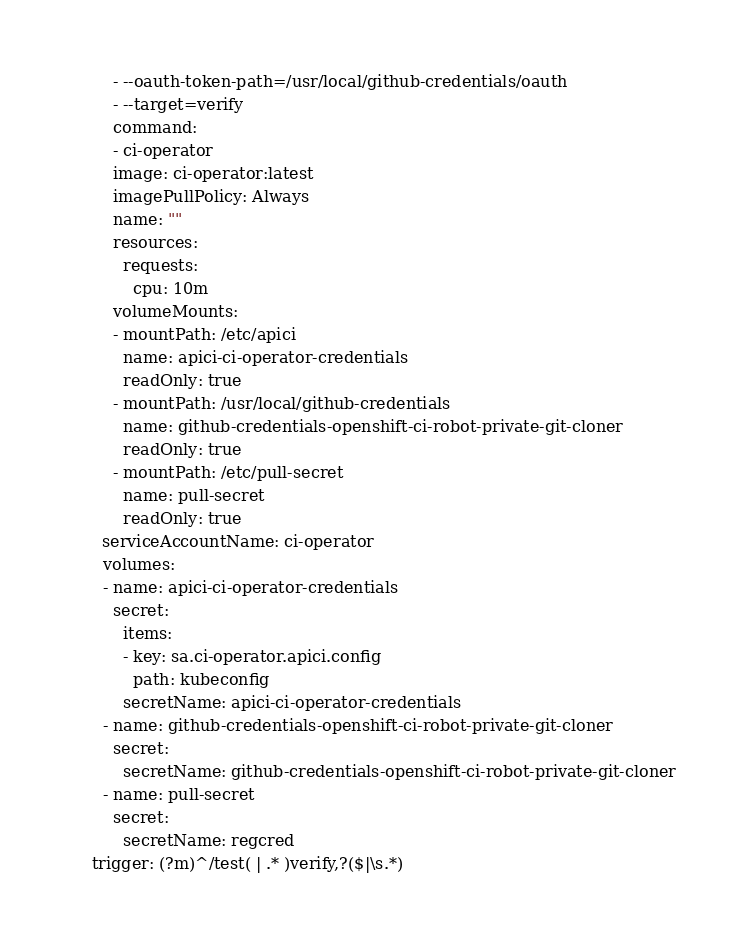<code> <loc_0><loc_0><loc_500><loc_500><_YAML_>        - --oauth-token-path=/usr/local/github-credentials/oauth
        - --target=verify
        command:
        - ci-operator
        image: ci-operator:latest
        imagePullPolicy: Always
        name: ""
        resources:
          requests:
            cpu: 10m
        volumeMounts:
        - mountPath: /etc/apici
          name: apici-ci-operator-credentials
          readOnly: true
        - mountPath: /usr/local/github-credentials
          name: github-credentials-openshift-ci-robot-private-git-cloner
          readOnly: true
        - mountPath: /etc/pull-secret
          name: pull-secret
          readOnly: true
      serviceAccountName: ci-operator
      volumes:
      - name: apici-ci-operator-credentials
        secret:
          items:
          - key: sa.ci-operator.apici.config
            path: kubeconfig
          secretName: apici-ci-operator-credentials
      - name: github-credentials-openshift-ci-robot-private-git-cloner
        secret:
          secretName: github-credentials-openshift-ci-robot-private-git-cloner
      - name: pull-secret
        secret:
          secretName: regcred
    trigger: (?m)^/test( | .* )verify,?($|\s.*)
</code> 